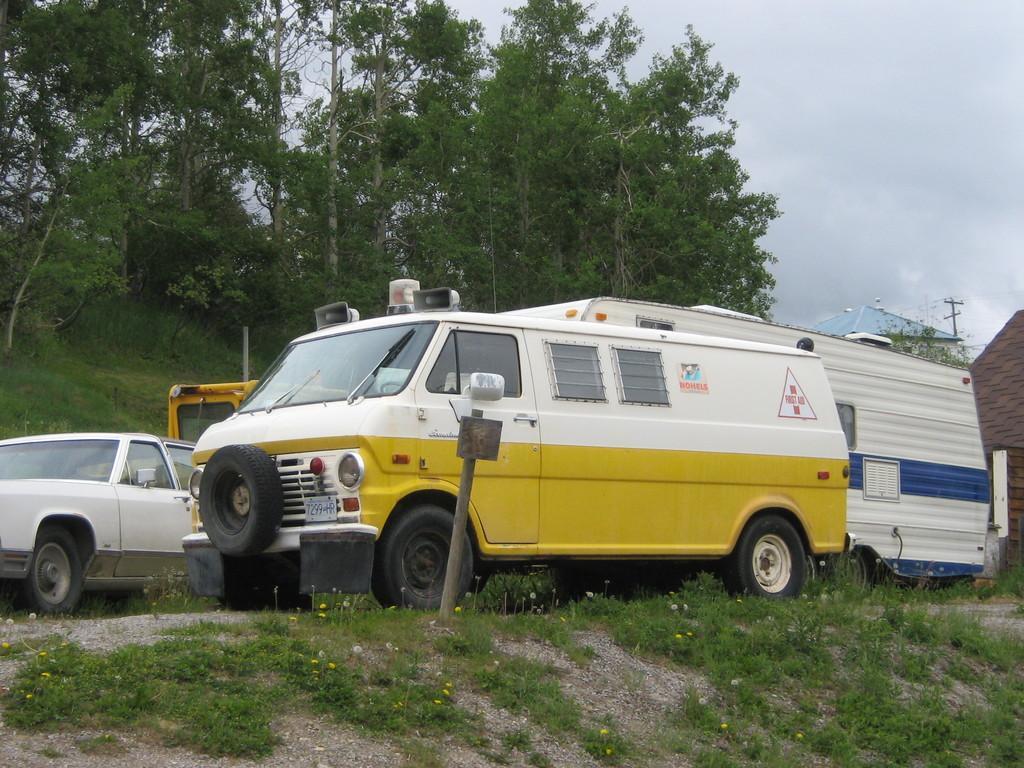Describe this image in one or two sentences. In this image we can see a few vehicles, in the background there are few plants, grass,trees, buildings, a pole and sky. 